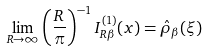Convert formula to latex. <formula><loc_0><loc_0><loc_500><loc_500>\lim _ { R \to \infty } \left ( \frac { R } { \pi } \right ) ^ { - 1 } I _ { R \beta } ^ { ( 1 ) } ( x ) = \hat { \rho } _ { \beta } ( \xi )</formula> 